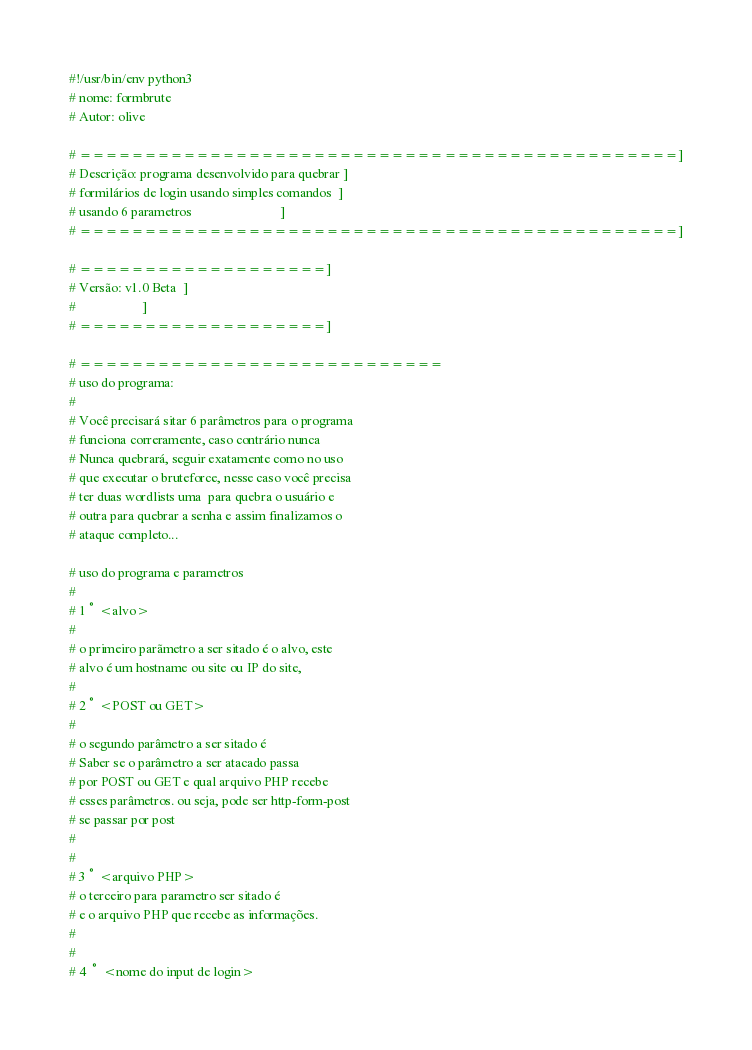Convert code to text. <code><loc_0><loc_0><loc_500><loc_500><_Python_>#!/usr/bin/env python3
# nome: formbrute
# Autor: olive

# ==============================================]
# Descrição: programa desenvolvido para quebrar ]
# formilários de login usando simples comandos  ]
# usando 6 parametros                           ]
# ==============================================]

# ===================]
# Versão: v1.0 Beta  ]
#                    ]
# ===================]

# ============================
# uso do programa:
# 
# Você precisará sitar 6 parâmetros para o programa
# funciona correramente, caso contrário nunca
# Nunca quebrará, seguir exatamente como no uso
# que executar o bruteforce, nesse caso você precisa
# ter duas wordlists uma  para quebra o usuário e 
# outra para quebrar a senha e assim finalizamos o
# ataque completo...

# uso do programa e parametros
#  
# 1° <alvo>
#
# o primeiro parãmetro a ser sitado é o alvo, este
# alvo é um hostname ou site ou IP do site,
#
# 2° <POST ou GET>
# 
# o segundo parâmetro a ser sitado é 
# Saber se o parâmetro a ser atacado passa
# por POST ou GET e qual arquivo PHP recebe 
# esses parâmetros. ou seja, pode ser http-form-post
# se passar por post
# 
#
# 3° <arquivo PHP>
# o terceiro para parametro ser sitado é
# e o arquivo PHP que recebe as informações.
#
#
# 4 ° <nome do input de login></code> 